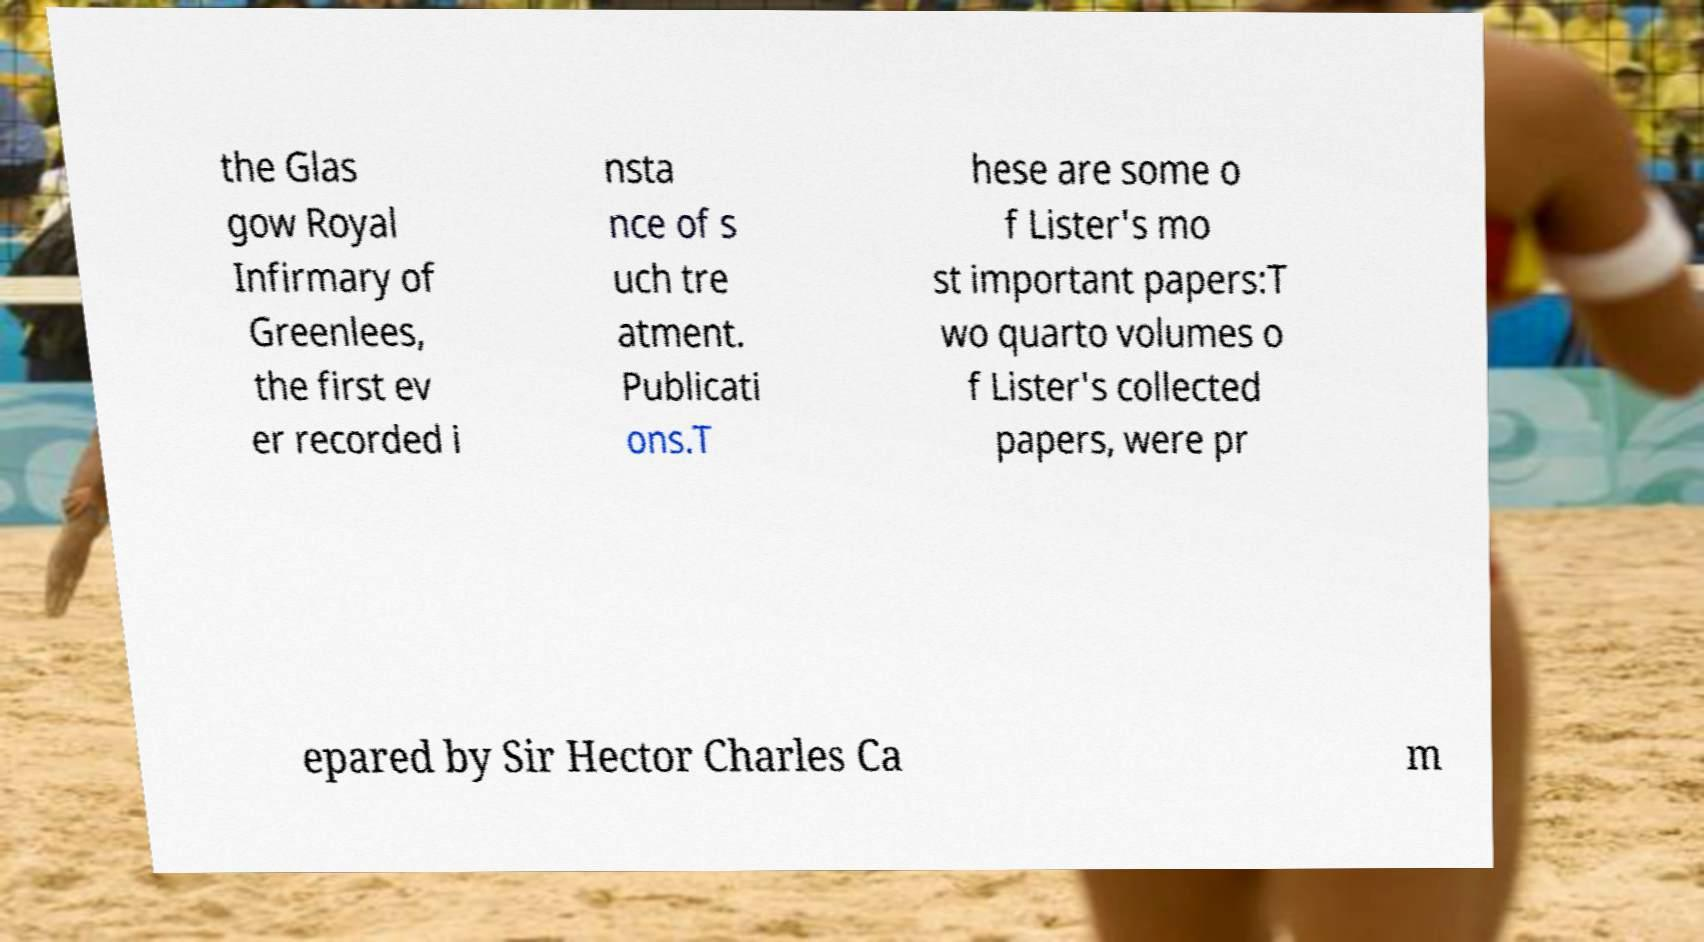There's text embedded in this image that I need extracted. Can you transcribe it verbatim? the Glas gow Royal Infirmary of Greenlees, the first ev er recorded i nsta nce of s uch tre atment. Publicati ons.T hese are some o f Lister's mo st important papers:T wo quarto volumes o f Lister's collected papers, were pr epared by Sir Hector Charles Ca m 